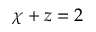<formula> <loc_0><loc_0><loc_500><loc_500>\chi + z = 2</formula> 